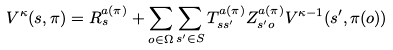<formula> <loc_0><loc_0><loc_500><loc_500>V ^ { \kappa } ( s , \pi ) = R ^ { a ( \pi ) } _ { s } + \sum _ { o \in \Omega } \sum _ { s ^ { \prime } \in S } T ^ { a ( \pi ) } _ { s s ^ { \prime } } Z ^ { a ( \pi ) } _ { s ^ { \prime } o } V ^ { \kappa - 1 } ( s ^ { \prime } , \pi ( o ) )</formula> 